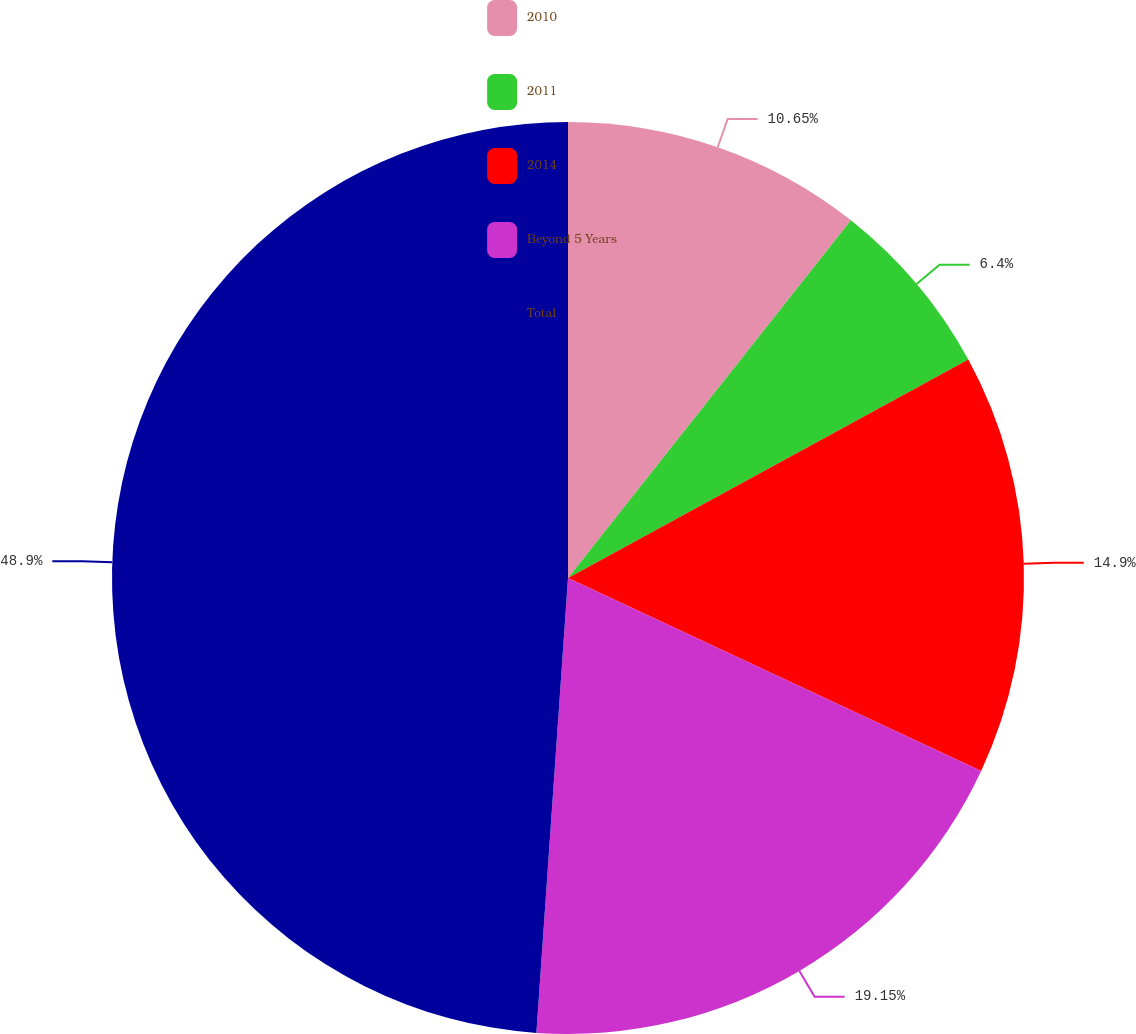Convert chart. <chart><loc_0><loc_0><loc_500><loc_500><pie_chart><fcel>2010<fcel>2011<fcel>2014<fcel>Beyond 5 Years<fcel>Total<nl><fcel>10.65%<fcel>6.4%<fcel>14.9%<fcel>19.15%<fcel>48.89%<nl></chart> 